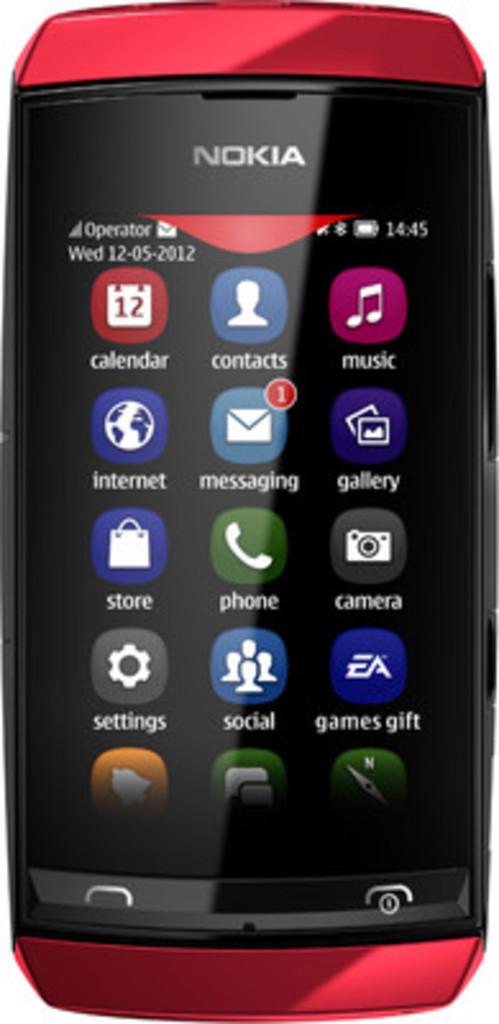What brand of phone is this?
Give a very brief answer. Nokia. What is the first icon on the top left for?
Provide a short and direct response. Calendar. 